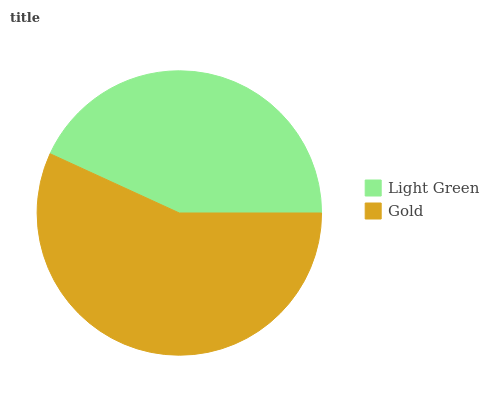Is Light Green the minimum?
Answer yes or no. Yes. Is Gold the maximum?
Answer yes or no. Yes. Is Gold the minimum?
Answer yes or no. No. Is Gold greater than Light Green?
Answer yes or no. Yes. Is Light Green less than Gold?
Answer yes or no. Yes. Is Light Green greater than Gold?
Answer yes or no. No. Is Gold less than Light Green?
Answer yes or no. No. Is Gold the high median?
Answer yes or no. Yes. Is Light Green the low median?
Answer yes or no. Yes. Is Light Green the high median?
Answer yes or no. No. Is Gold the low median?
Answer yes or no. No. 